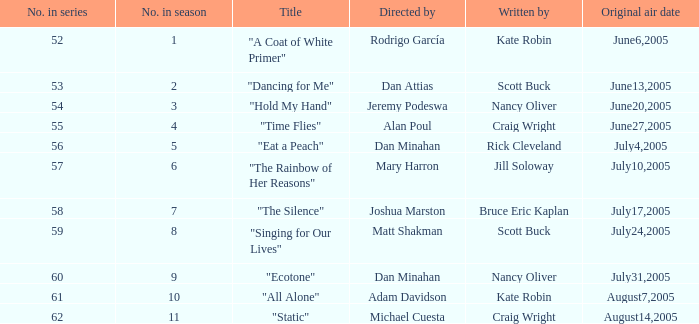What was the name of the episode that was directed by Mary Harron? "The Rainbow of Her Reasons". 